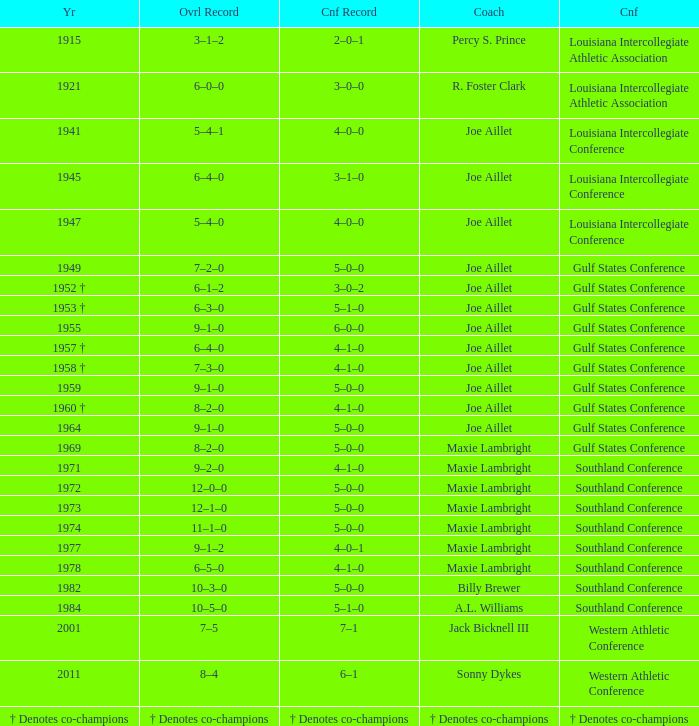What is the conference record for the year of 1971? 4–1–0. 